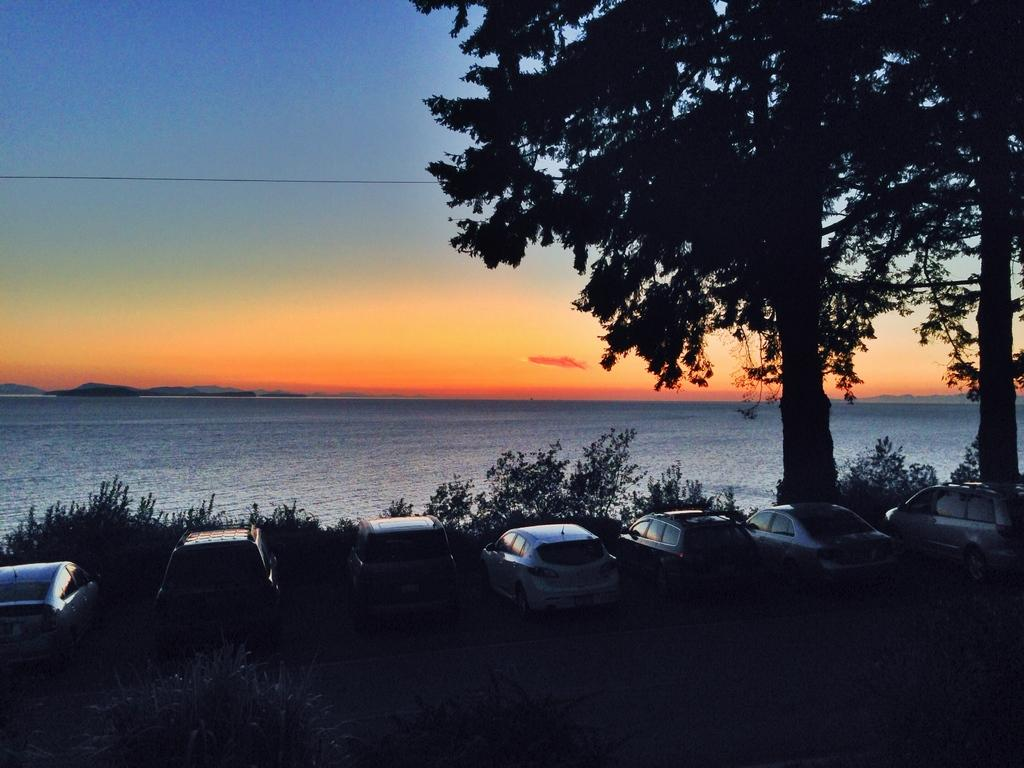How would you describe the weather in the image? The climate is pleasant in the image. What is the main feature visible in the background? There is a sea in the image. What type of vegetation is present near the sea? There are two trees and plants in front of the sea. Can you describe the arrangement of the cars in the image? Many cars are parked behind the plants in a row. What type of error can be seen in the image? There is no error present in the image. How does the image make you feel? The image itself does not evoke a specific feeling, as it is an inanimate object. 